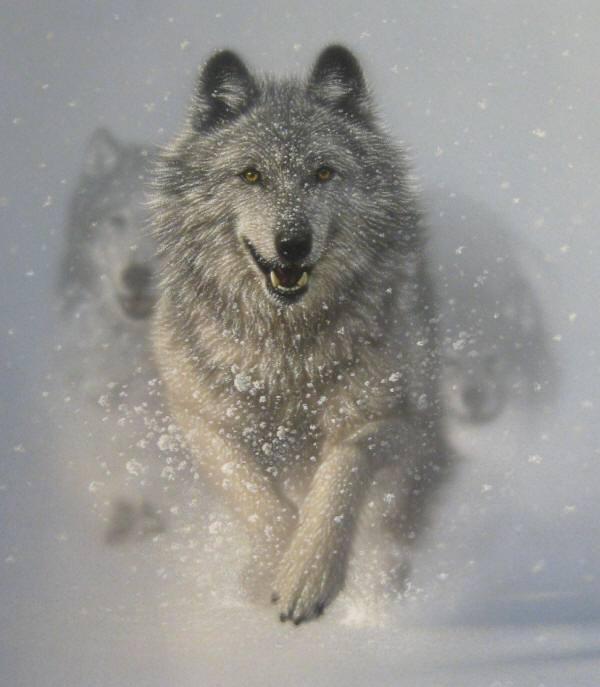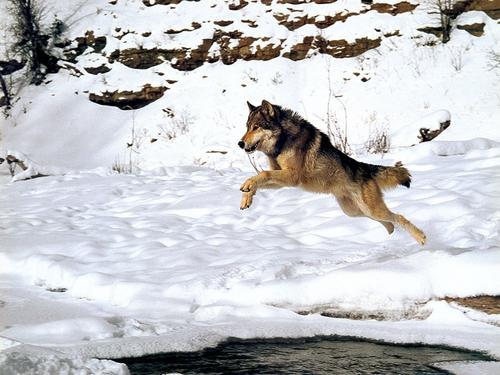The first image is the image on the left, the second image is the image on the right. For the images shown, is this caption "there are 5 wolves running in the snow in the image pair" true? Answer yes or no. No. 